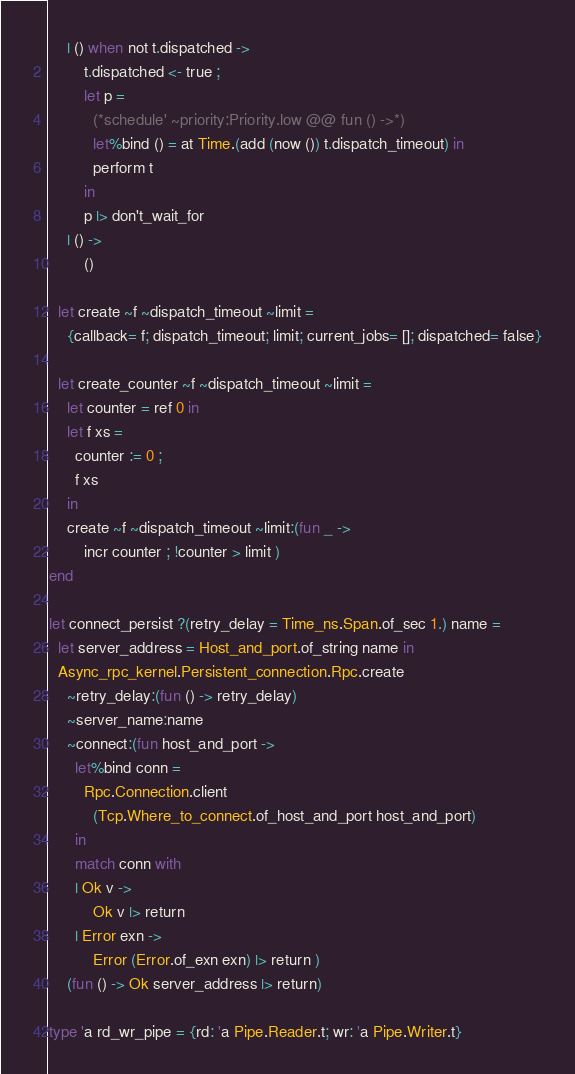Convert code to text. <code><loc_0><loc_0><loc_500><loc_500><_OCaml_>    | () when not t.dispatched ->
        t.dispatched <- true ;
        let p =
          (*schedule' ~priority:Priority.low @@ fun () ->*)
          let%bind () = at Time.(add (now ()) t.dispatch_timeout) in
          perform t
        in
        p |> don't_wait_for
    | () ->
        ()

  let create ~f ~dispatch_timeout ~limit =
    {callback= f; dispatch_timeout; limit; current_jobs= []; dispatched= false}

  let create_counter ~f ~dispatch_timeout ~limit =
    let counter = ref 0 in
    let f xs =
      counter := 0 ;
      f xs
    in
    create ~f ~dispatch_timeout ~limit:(fun _ ->
        incr counter ; !counter > limit )
end

let connect_persist ?(retry_delay = Time_ns.Span.of_sec 1.) name =
  let server_address = Host_and_port.of_string name in
  Async_rpc_kernel.Persistent_connection.Rpc.create
    ~retry_delay:(fun () -> retry_delay)
    ~server_name:name
    ~connect:(fun host_and_port ->
      let%bind conn =
        Rpc.Connection.client
          (Tcp.Where_to_connect.of_host_and_port host_and_port)
      in
      match conn with
      | Ok v ->
          Ok v |> return
      | Error exn ->
          Error (Error.of_exn exn) |> return )
    (fun () -> Ok server_address |> return)

type 'a rd_wr_pipe = {rd: 'a Pipe.Reader.t; wr: 'a Pipe.Writer.t}
</code> 